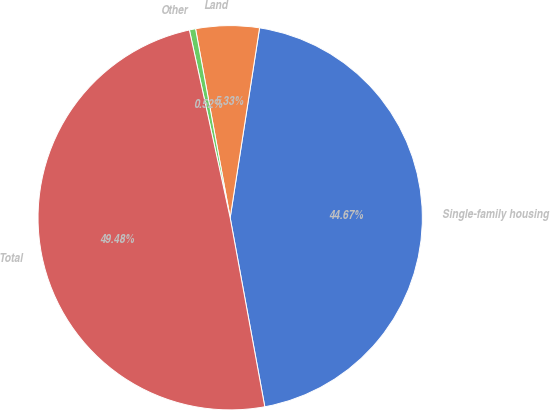Convert chart. <chart><loc_0><loc_0><loc_500><loc_500><pie_chart><fcel>Single-family housing<fcel>Land<fcel>Other<fcel>Total<nl><fcel>44.67%<fcel>5.33%<fcel>0.52%<fcel>49.48%<nl></chart> 